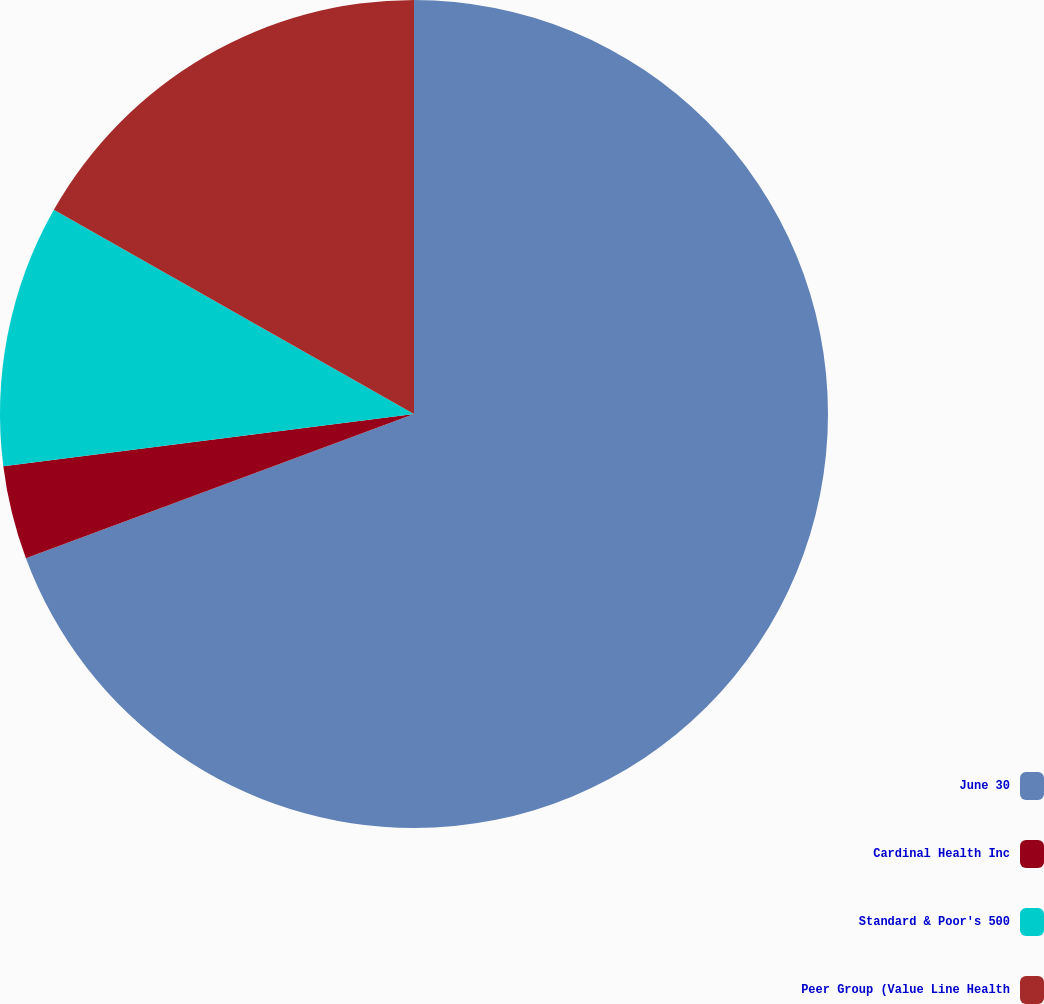Convert chart. <chart><loc_0><loc_0><loc_500><loc_500><pie_chart><fcel>June 30<fcel>Cardinal Health Inc<fcel>Standard & Poor's 500<fcel>Peer Group (Value Line Health<nl><fcel>69.34%<fcel>3.65%<fcel>10.22%<fcel>16.79%<nl></chart> 